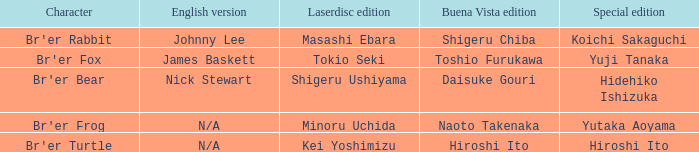What is the special edition for the english version of james baskett? Yuji Tanaka. 